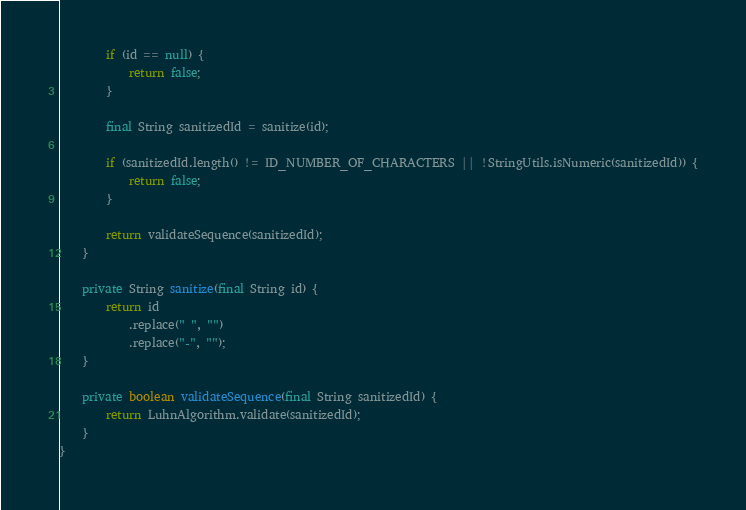<code> <loc_0><loc_0><loc_500><loc_500><_Java_>        if (id == null) {
            return false;
        }

        final String sanitizedId = sanitize(id);

        if (sanitizedId.length() != ID_NUMBER_OF_CHARACTERS || !StringUtils.isNumeric(sanitizedId)) {
            return false;
        }

        return validateSequence(sanitizedId);
    }

    private String sanitize(final String id) {
        return id
            .replace(" ", "")
            .replace("-", "");
    }

    private boolean validateSequence(final String sanitizedId) {
        return LuhnAlgorithm.validate(sanitizedId);
    }
}
</code> 